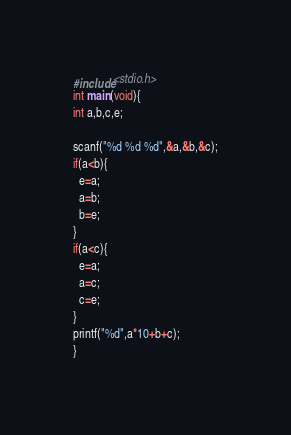<code> <loc_0><loc_0><loc_500><loc_500><_C_>#include<stdio.h>
int main(void){
int a,b,c,e;

scanf("%d %d %d",&a,&b,&c);
if(a<b){
  e=a;
  a=b;
  b=e;
}
if(a<c){
  e=a;
  a=c;
  c=e;
}
printf("%d",a*10+b+c);
}</code> 